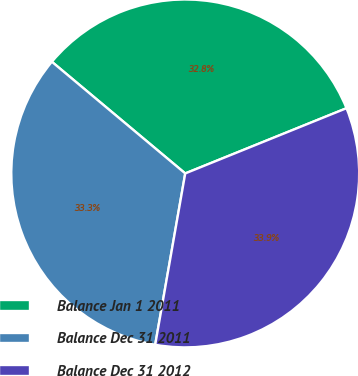<chart> <loc_0><loc_0><loc_500><loc_500><pie_chart><fcel>Balance Jan 1 2011<fcel>Balance Dec 31 2011<fcel>Balance Dec 31 2012<nl><fcel>32.79%<fcel>33.33%<fcel>33.88%<nl></chart> 